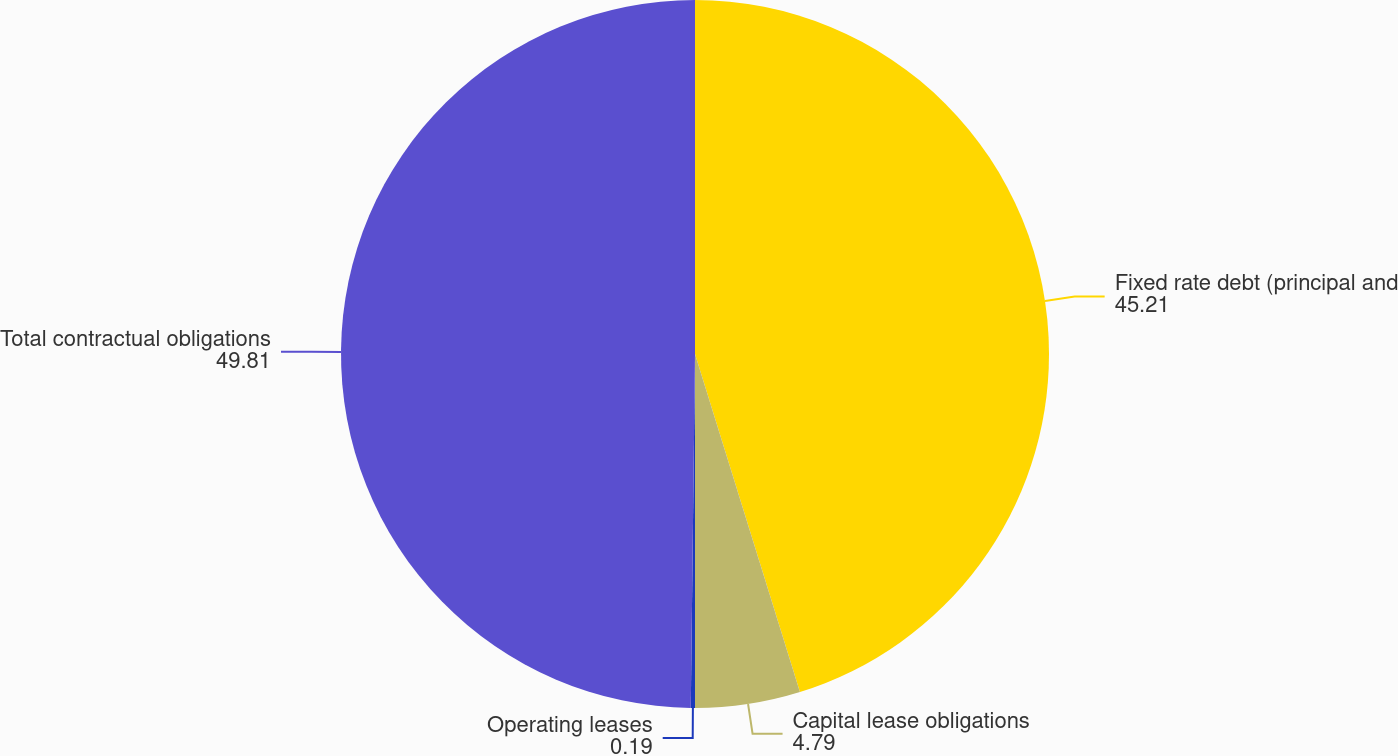Convert chart. <chart><loc_0><loc_0><loc_500><loc_500><pie_chart><fcel>Fixed rate debt (principal and<fcel>Capital lease obligations<fcel>Operating leases<fcel>Total contractual obligations<nl><fcel>45.21%<fcel>4.79%<fcel>0.19%<fcel>49.81%<nl></chart> 